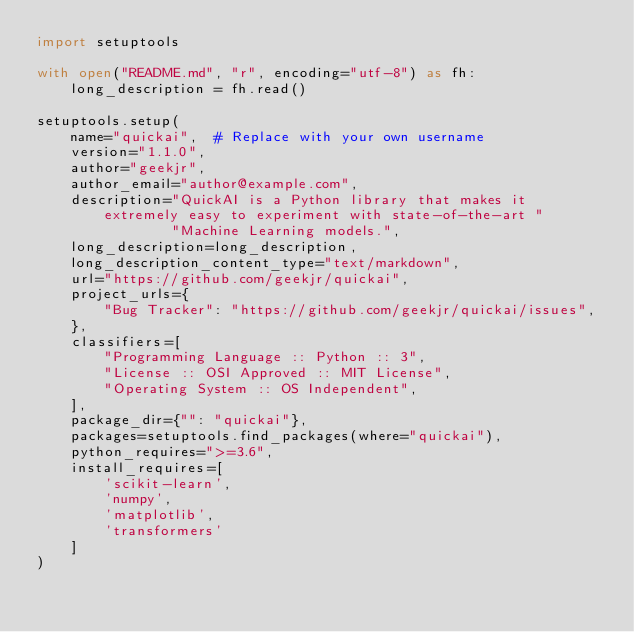<code> <loc_0><loc_0><loc_500><loc_500><_Python_>import setuptools

with open("README.md", "r", encoding="utf-8") as fh:
    long_description = fh.read()

setuptools.setup(
    name="quickai",  # Replace with your own username
    version="1.1.0",
    author="geekjr",
    author_email="author@example.com",
    description="QuickAI is a Python library that makes it extremely easy to experiment with state-of-the-art "
                "Machine Learning models.",
    long_description=long_description,
    long_description_content_type="text/markdown",
    url="https://github.com/geekjr/quickai",
    project_urls={
        "Bug Tracker": "https://github.com/geekjr/quickai/issues",
    },
    classifiers=[
        "Programming Language :: Python :: 3",
        "License :: OSI Approved :: MIT License",
        "Operating System :: OS Independent",
    ],
    package_dir={"": "quickai"},
    packages=setuptools.find_packages(where="quickai"),
    python_requires=">=3.6",
    install_requires=[
        'scikit-learn',
        'numpy',
        'matplotlib',
        'transformers'
    ]
)
</code> 